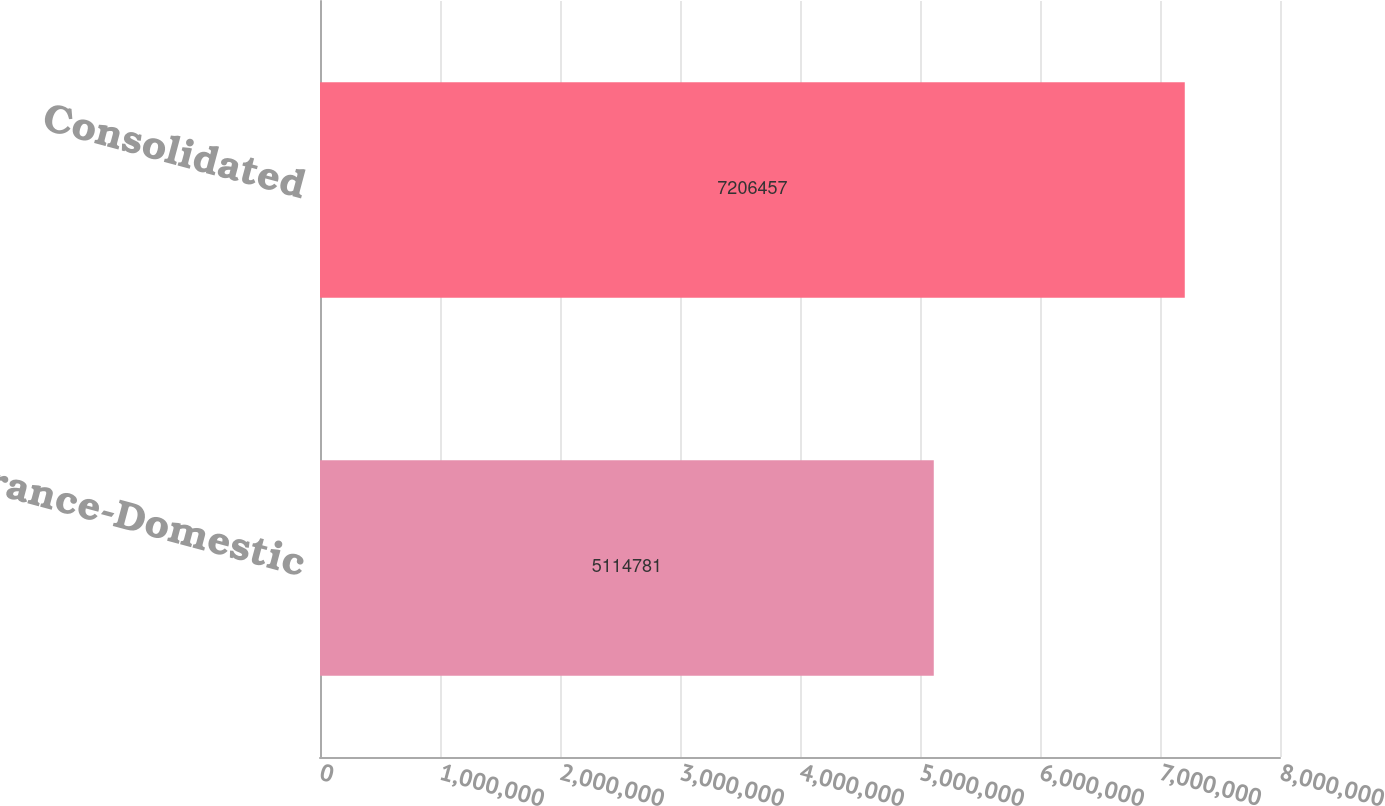<chart> <loc_0><loc_0><loc_500><loc_500><bar_chart><fcel>Insurance-Domestic<fcel>Consolidated<nl><fcel>5.11478e+06<fcel>7.20646e+06<nl></chart> 